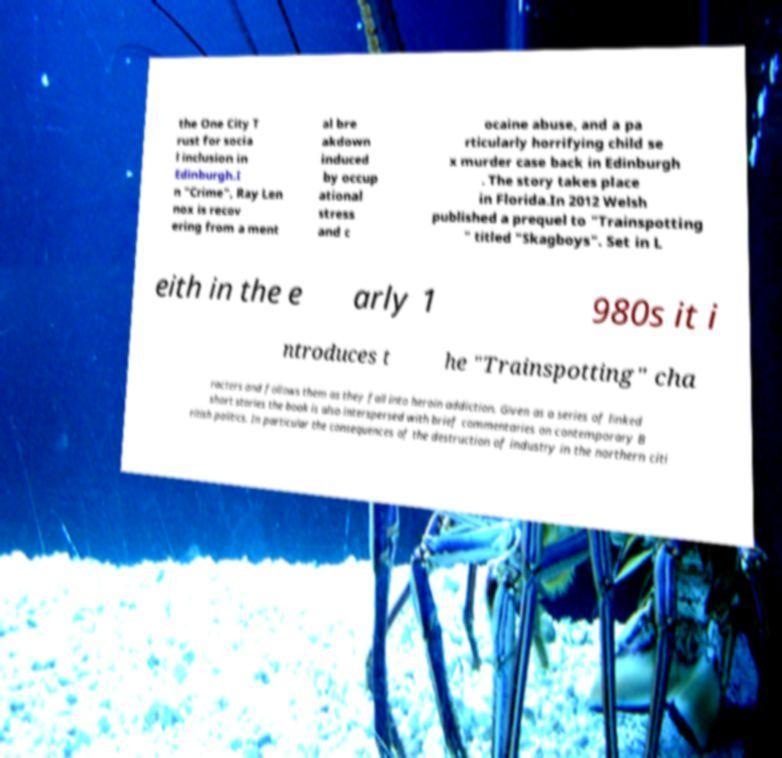What messages or text are displayed in this image? I need them in a readable, typed format. the One City T rust for socia l inclusion in Edinburgh.I n "Crime", Ray Len nox is recov ering from a ment al bre akdown induced by occup ational stress and c ocaine abuse, and a pa rticularly horrifying child se x murder case back in Edinburgh . The story takes place in Florida.In 2012 Welsh published a prequel to "Trainspotting " titled "Skagboys". Set in L eith in the e arly 1 980s it i ntroduces t he "Trainspotting" cha racters and follows them as they fall into heroin addiction. Given as a series of linked short stories the book is also interspersed with brief commentaries on contemporary B ritish politics. In particular the consequences of the destruction of industry in the northern citi 